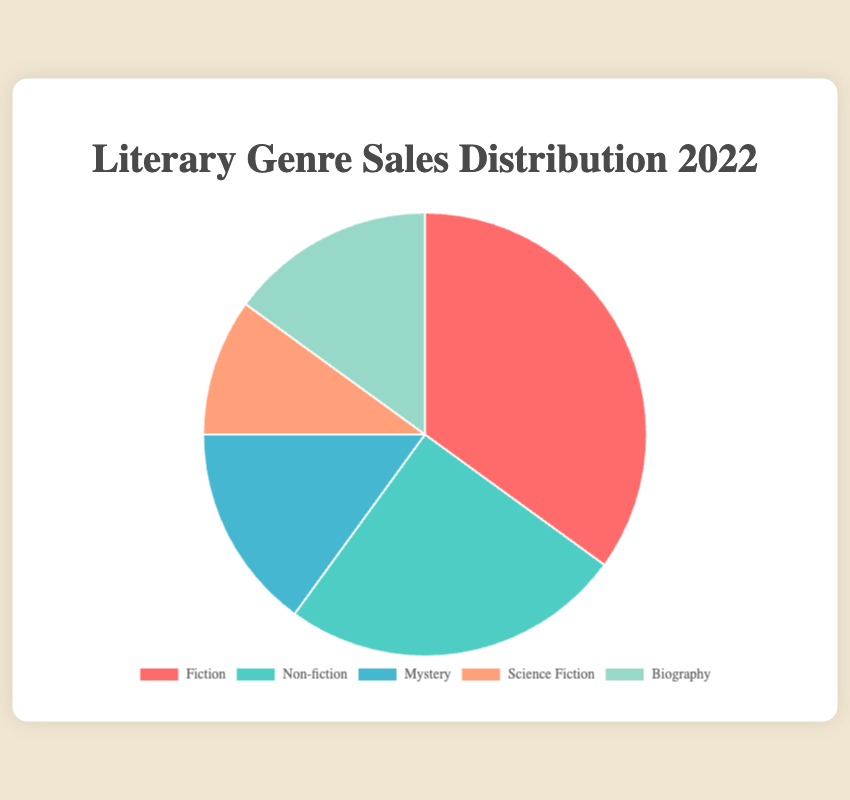What percentage of book sales in 2022 were from fiction and mystery combined? To find the combined percentage of fiction and mystery, add the individual percentages: 35% (fiction) + 15% (mystery) = 50%
Answer: 50% Which genre had the second highest sales percentage in 2022? The genres and their percentages are: Fiction (35%), Non-fiction (25%), Mystery (15%), Science Fiction (10%), and Biography (15%). The genre with the second highest percentage is Non-fiction.
Answer: Non-fiction Is the percentage of biography sales equal to that of mystery sales? The percentage of biography sales is 15%, and so is the percentage of mystery sales. Thus, they are equal.
Answer: Yes How does the percentage of non-fiction sales compare to that of science fiction? Non-fiction has 25% and Science Fiction has 10%. Non-fiction has a higher percentage of sales compared to Science Fiction.
Answer: Non-fiction has a higher percentage What is the percentage difference between the genre with the highest sales and the genre with the lowest sales? The highest sales percentage is Fiction (35%) and the lowest is Science Fiction (10%). The difference is 35% - 10% = 25%.
Answer: 25% What colors represent the genres with the smallest and largest sales percentages? The genre with the smallest sales percentage (Science Fiction, 10%) is represented by a peach color, and the genre with the largest sales percentage (Fiction, 35%) is represented by a red color.
Answer: Red (largest), Peach (smallest) Of the three genres with the lowest sales percentages, what is their average sales percentage? The three genres with the lowest sales percentages are Mystery (15%), Science Fiction (10%), and Biography (15%). The average is (15 + 10 + 15) / 3 = 13.33%.
Answer: 13.33% How does non-fiction sales compare visually against mystery sales in the chart? Non-fiction (25%) has a larger visual representation in the chart compared to Mystery (15%).
Answer: Non-fiction has a larger visual representation What is the total percentage of sales for genres other than fiction and non-fiction? First, add the percentages of Fiction and Non-fiction: 35% + 25% = 60%. Then subtract from 100% to find the remaining: 100% - 60% = 40%.
Answer: 40% Which genre has the same sales percentage as the genre represented in a light green color? The genre represented by light green is Biography, which has the same sales percentage as Mystery (15%).
Answer: Biography 